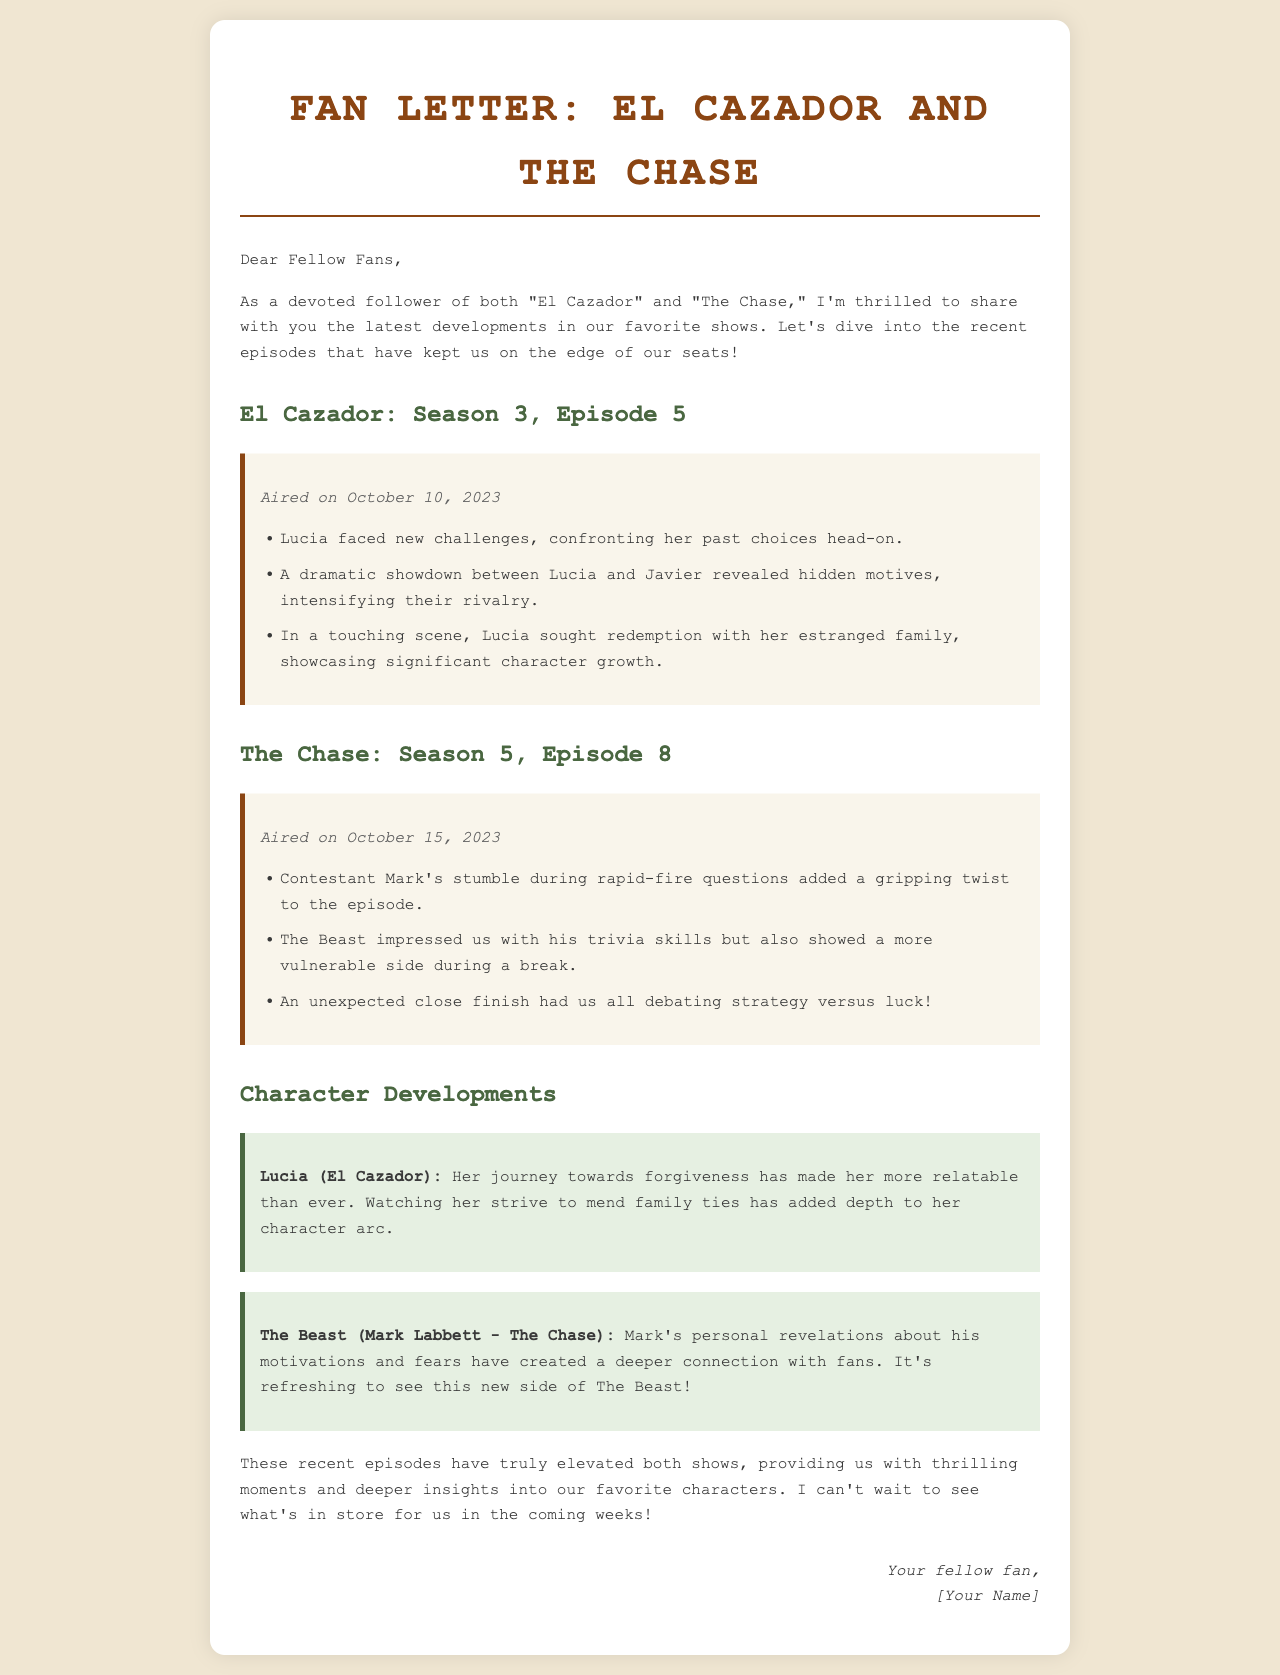what season and episode of El Cazador aired on October 10, 2023? The document specifies that it is Season 3, Episode 5.
Answer: Season 3, Episode 5 what significant event occurred between Lucia and Javier in El Cazador? The document mentions a dramatic showdown that revealed hidden motives.
Answer: Dramatic showdown who sought redemption with their estranged family in El Cazador? The letter indicates that Lucia sought redemption with her family.
Answer: Lucia what unexpected event occurred with contestant Mark during The Chase? The document states that Mark stumbled during rapid-fire questions.
Answer: Stumble what did The Beast reveal about himself in The Chase? The letter highlights that The Beast showed a more vulnerable side.
Answer: Vulnerable side what is the title of the show that features Lucia? The letter clearly states the show is called "El Cazador."
Answer: El Cazador how does the recent character development of Lucia affect her relatability? The document mentions her journey towards forgiveness has made her more relatable.
Answer: More relatable what is the primary focus of the letter? The document emphasizes the summary of recent episodes and character developments.
Answer: Summary of recent episodes 